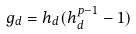<formula> <loc_0><loc_0><loc_500><loc_500>g _ { d } = h _ { d } ( h _ { d } ^ { p - 1 } - 1 )</formula> 